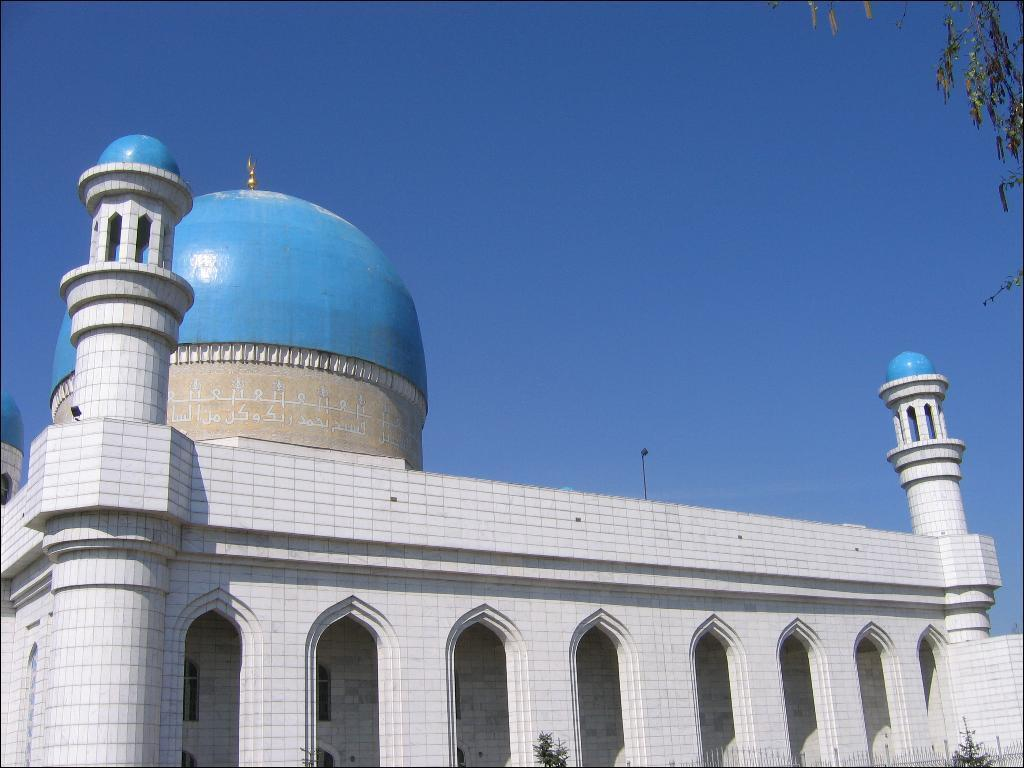What type of building is in the image? There is a mosque in the image. What other natural elements can be seen in the image? There is a tree and plants in the image. What is visible in the background of the image? The sky is visible in the image. How many pages are there in the mosque in the image? There are no pages present in the image, as it features a mosque, tree, plants, and the sky. 